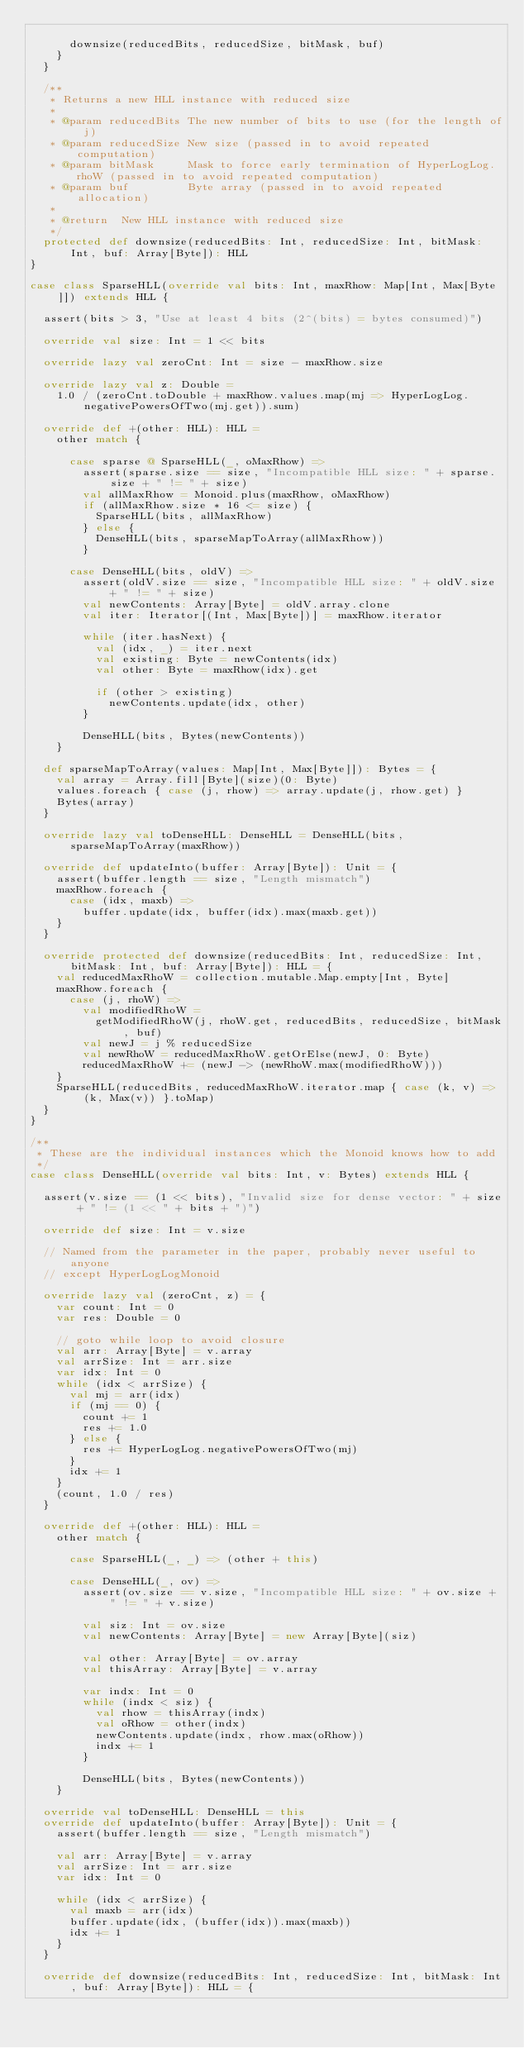Convert code to text. <code><loc_0><loc_0><loc_500><loc_500><_Scala_>
      downsize(reducedBits, reducedSize, bitMask, buf)
    }
  }

  /**
   * Returns a new HLL instance with reduced size
   *
   * @param reducedBits The new number of bits to use (for the length of j)
   * @param reducedSize New size (passed in to avoid repeated computation)
   * @param bitMask     Mask to force early termination of HyperLogLog.rhoW (passed in to avoid repeated computation)
   * @param buf         Byte array (passed in to avoid repeated allocation)
   *
   * @return  New HLL instance with reduced size
   */
  protected def downsize(reducedBits: Int, reducedSize: Int, bitMask: Int, buf: Array[Byte]): HLL
}

case class SparseHLL(override val bits: Int, maxRhow: Map[Int, Max[Byte]]) extends HLL {

  assert(bits > 3, "Use at least 4 bits (2^(bits) = bytes consumed)")

  override val size: Int = 1 << bits

  override lazy val zeroCnt: Int = size - maxRhow.size

  override lazy val z: Double =
    1.0 / (zeroCnt.toDouble + maxRhow.values.map(mj => HyperLogLog.negativePowersOfTwo(mj.get)).sum)

  override def +(other: HLL): HLL =
    other match {

      case sparse @ SparseHLL(_, oMaxRhow) =>
        assert(sparse.size == size, "Incompatible HLL size: " + sparse.size + " != " + size)
        val allMaxRhow = Monoid.plus(maxRhow, oMaxRhow)
        if (allMaxRhow.size * 16 <= size) {
          SparseHLL(bits, allMaxRhow)
        } else {
          DenseHLL(bits, sparseMapToArray(allMaxRhow))
        }

      case DenseHLL(bits, oldV) =>
        assert(oldV.size == size, "Incompatible HLL size: " + oldV.size + " != " + size)
        val newContents: Array[Byte] = oldV.array.clone
        val iter: Iterator[(Int, Max[Byte])] = maxRhow.iterator

        while (iter.hasNext) {
          val (idx, _) = iter.next
          val existing: Byte = newContents(idx)
          val other: Byte = maxRhow(idx).get

          if (other > existing)
            newContents.update(idx, other)
        }

        DenseHLL(bits, Bytes(newContents))
    }

  def sparseMapToArray(values: Map[Int, Max[Byte]]): Bytes = {
    val array = Array.fill[Byte](size)(0: Byte)
    values.foreach { case (j, rhow) => array.update(j, rhow.get) }
    Bytes(array)
  }

  override lazy val toDenseHLL: DenseHLL = DenseHLL(bits, sparseMapToArray(maxRhow))

  override def updateInto(buffer: Array[Byte]): Unit = {
    assert(buffer.length == size, "Length mismatch")
    maxRhow.foreach {
      case (idx, maxb) =>
        buffer.update(idx, buffer(idx).max(maxb.get))
    }
  }

  override protected def downsize(reducedBits: Int, reducedSize: Int, bitMask: Int, buf: Array[Byte]): HLL = {
    val reducedMaxRhoW = collection.mutable.Map.empty[Int, Byte]
    maxRhow.foreach {
      case (j, rhoW) =>
        val modifiedRhoW =
          getModifiedRhoW(j, rhoW.get, reducedBits, reducedSize, bitMask, buf)
        val newJ = j % reducedSize
        val newRhoW = reducedMaxRhoW.getOrElse(newJ, 0: Byte)
        reducedMaxRhoW += (newJ -> (newRhoW.max(modifiedRhoW)))
    }
    SparseHLL(reducedBits, reducedMaxRhoW.iterator.map { case (k, v) => (k, Max(v)) }.toMap)
  }
}

/**
 * These are the individual instances which the Monoid knows how to add
 */
case class DenseHLL(override val bits: Int, v: Bytes) extends HLL {

  assert(v.size == (1 << bits), "Invalid size for dense vector: " + size + " != (1 << " + bits + ")")

  override def size: Int = v.size

  // Named from the parameter in the paper, probably never useful to anyone
  // except HyperLogLogMonoid

  override lazy val (zeroCnt, z) = {
    var count: Int = 0
    var res: Double = 0

    // goto while loop to avoid closure
    val arr: Array[Byte] = v.array
    val arrSize: Int = arr.size
    var idx: Int = 0
    while (idx < arrSize) {
      val mj = arr(idx)
      if (mj == 0) {
        count += 1
        res += 1.0
      } else {
        res += HyperLogLog.negativePowersOfTwo(mj)
      }
      idx += 1
    }
    (count, 1.0 / res)
  }

  override def +(other: HLL): HLL =
    other match {

      case SparseHLL(_, _) => (other + this)

      case DenseHLL(_, ov) =>
        assert(ov.size == v.size, "Incompatible HLL size: " + ov.size + " != " + v.size)

        val siz: Int = ov.size
        val newContents: Array[Byte] = new Array[Byte](siz)

        val other: Array[Byte] = ov.array
        val thisArray: Array[Byte] = v.array

        var indx: Int = 0
        while (indx < siz) {
          val rhow = thisArray(indx)
          val oRhow = other(indx)
          newContents.update(indx, rhow.max(oRhow))
          indx += 1
        }

        DenseHLL(bits, Bytes(newContents))
    }

  override val toDenseHLL: DenseHLL = this
  override def updateInto(buffer: Array[Byte]): Unit = {
    assert(buffer.length == size, "Length mismatch")

    val arr: Array[Byte] = v.array
    val arrSize: Int = arr.size
    var idx: Int = 0

    while (idx < arrSize) {
      val maxb = arr(idx)
      buffer.update(idx, (buffer(idx)).max(maxb))
      idx += 1
    }
  }

  override def downsize(reducedBits: Int, reducedSize: Int, bitMask: Int, buf: Array[Byte]): HLL = {</code> 